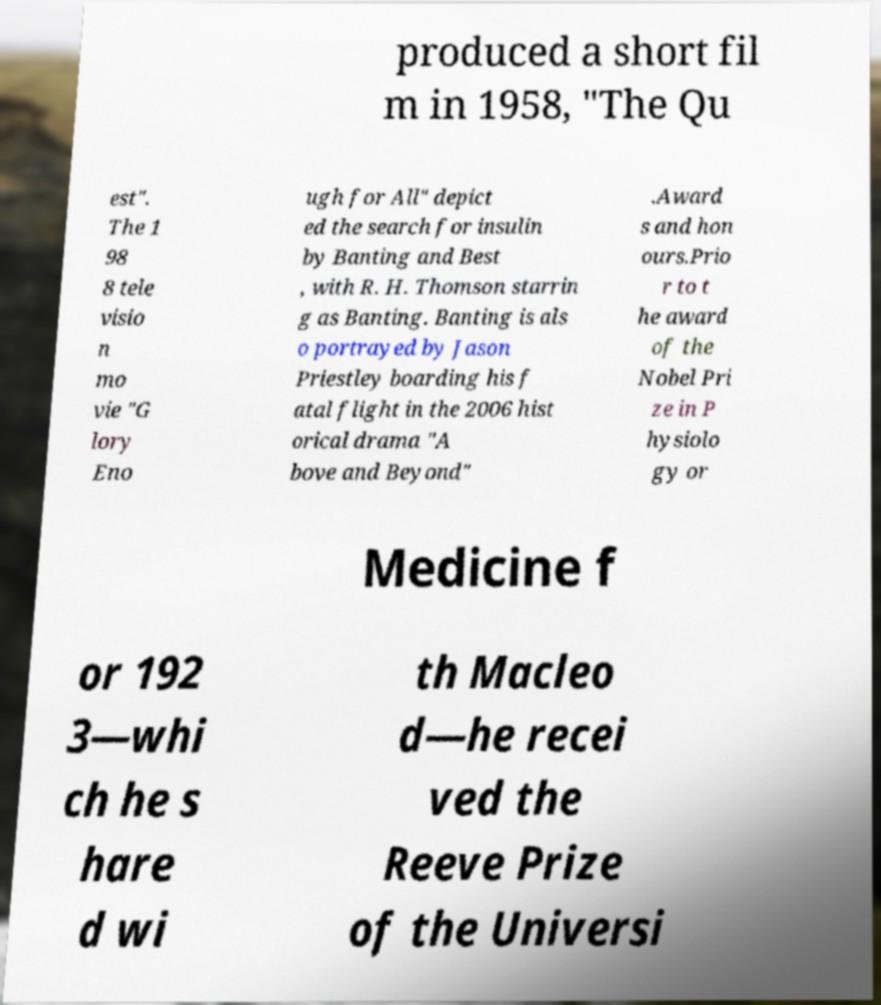Can you accurately transcribe the text from the provided image for me? produced a short fil m in 1958, "The Qu est". The 1 98 8 tele visio n mo vie "G lory Eno ugh for All" depict ed the search for insulin by Banting and Best , with R. H. Thomson starrin g as Banting. Banting is als o portrayed by Jason Priestley boarding his f atal flight in the 2006 hist orical drama "A bove and Beyond" .Award s and hon ours.Prio r to t he award of the Nobel Pri ze in P hysiolo gy or Medicine f or 192 3—whi ch he s hare d wi th Macleo d—he recei ved the Reeve Prize of the Universi 